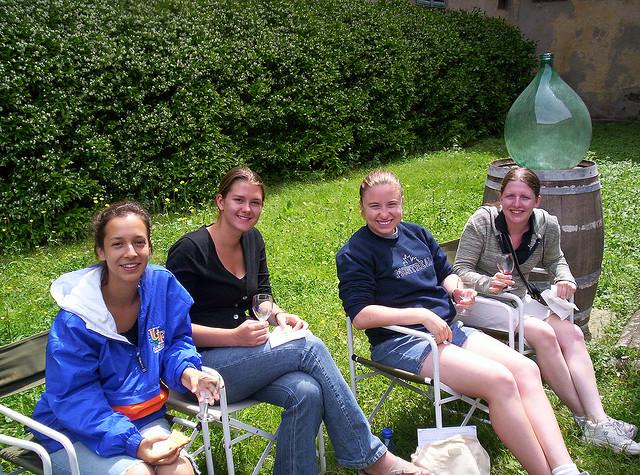What is the gender of the two individuals?
Concise answer only. Female. Do these people appear to be happy?
Be succinct. Yes. How many people in this photo?
Short answer required. 4. The lady on the left has what colored jacket?
Give a very brief answer. Blue. What is that big green thing?
Answer briefly. Balloon. 